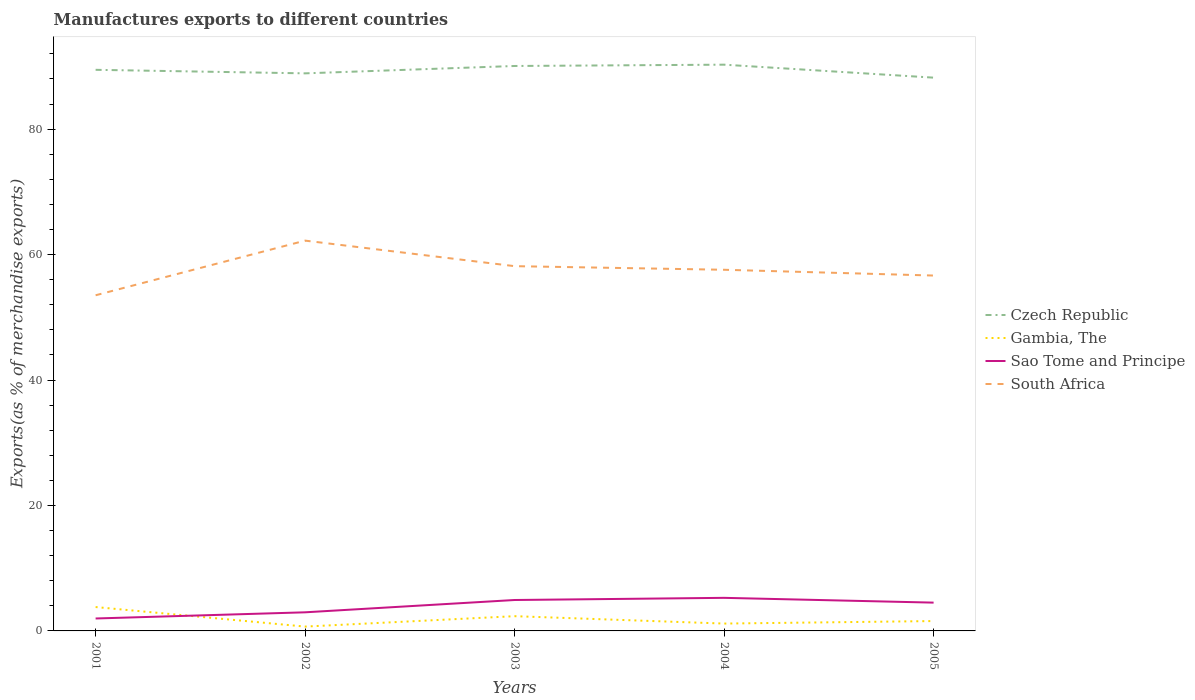Does the line corresponding to Gambia, The intersect with the line corresponding to Sao Tome and Principe?
Your answer should be compact. Yes. Is the number of lines equal to the number of legend labels?
Your answer should be compact. Yes. Across all years, what is the maximum percentage of exports to different countries in Sao Tome and Principe?
Give a very brief answer. 1.98. What is the total percentage of exports to different countries in Czech Republic in the graph?
Make the answer very short. 0.68. What is the difference between the highest and the second highest percentage of exports to different countries in South Africa?
Provide a succinct answer. 8.71. How many lines are there?
Provide a short and direct response. 4. How many years are there in the graph?
Your answer should be compact. 5. Are the values on the major ticks of Y-axis written in scientific E-notation?
Give a very brief answer. No. Does the graph contain grids?
Offer a very short reply. No. Where does the legend appear in the graph?
Your answer should be compact. Center right. How many legend labels are there?
Provide a succinct answer. 4. How are the legend labels stacked?
Make the answer very short. Vertical. What is the title of the graph?
Ensure brevity in your answer.  Manufactures exports to different countries. What is the label or title of the Y-axis?
Your answer should be very brief. Exports(as % of merchandise exports). What is the Exports(as % of merchandise exports) of Czech Republic in 2001?
Your response must be concise. 89.45. What is the Exports(as % of merchandise exports) of Gambia, The in 2001?
Provide a short and direct response. 3.81. What is the Exports(as % of merchandise exports) of Sao Tome and Principe in 2001?
Offer a very short reply. 1.98. What is the Exports(as % of merchandise exports) in South Africa in 2001?
Give a very brief answer. 53.51. What is the Exports(as % of merchandise exports) in Czech Republic in 2002?
Provide a short and direct response. 88.89. What is the Exports(as % of merchandise exports) in Gambia, The in 2002?
Ensure brevity in your answer.  0.69. What is the Exports(as % of merchandise exports) of Sao Tome and Principe in 2002?
Your answer should be very brief. 2.97. What is the Exports(as % of merchandise exports) in South Africa in 2002?
Offer a terse response. 62.22. What is the Exports(as % of merchandise exports) in Czech Republic in 2003?
Offer a very short reply. 90.07. What is the Exports(as % of merchandise exports) of Gambia, The in 2003?
Provide a succinct answer. 2.35. What is the Exports(as % of merchandise exports) of Sao Tome and Principe in 2003?
Offer a very short reply. 4.93. What is the Exports(as % of merchandise exports) in South Africa in 2003?
Offer a very short reply. 58.15. What is the Exports(as % of merchandise exports) in Czech Republic in 2004?
Keep it short and to the point. 90.27. What is the Exports(as % of merchandise exports) of Gambia, The in 2004?
Your response must be concise. 1.17. What is the Exports(as % of merchandise exports) of Sao Tome and Principe in 2004?
Make the answer very short. 5.27. What is the Exports(as % of merchandise exports) of South Africa in 2004?
Give a very brief answer. 57.58. What is the Exports(as % of merchandise exports) of Czech Republic in 2005?
Offer a very short reply. 88.21. What is the Exports(as % of merchandise exports) in Gambia, The in 2005?
Offer a terse response. 1.57. What is the Exports(as % of merchandise exports) of Sao Tome and Principe in 2005?
Your answer should be compact. 4.51. What is the Exports(as % of merchandise exports) of South Africa in 2005?
Make the answer very short. 56.66. Across all years, what is the maximum Exports(as % of merchandise exports) of Czech Republic?
Keep it short and to the point. 90.27. Across all years, what is the maximum Exports(as % of merchandise exports) in Gambia, The?
Your answer should be compact. 3.81. Across all years, what is the maximum Exports(as % of merchandise exports) of Sao Tome and Principe?
Provide a short and direct response. 5.27. Across all years, what is the maximum Exports(as % of merchandise exports) in South Africa?
Make the answer very short. 62.22. Across all years, what is the minimum Exports(as % of merchandise exports) in Czech Republic?
Offer a terse response. 88.21. Across all years, what is the minimum Exports(as % of merchandise exports) of Gambia, The?
Provide a short and direct response. 0.69. Across all years, what is the minimum Exports(as % of merchandise exports) in Sao Tome and Principe?
Ensure brevity in your answer.  1.98. Across all years, what is the minimum Exports(as % of merchandise exports) in South Africa?
Ensure brevity in your answer.  53.51. What is the total Exports(as % of merchandise exports) of Czech Republic in the graph?
Your answer should be very brief. 446.89. What is the total Exports(as % of merchandise exports) of Gambia, The in the graph?
Your answer should be very brief. 9.59. What is the total Exports(as % of merchandise exports) in Sao Tome and Principe in the graph?
Make the answer very short. 19.66. What is the total Exports(as % of merchandise exports) in South Africa in the graph?
Your answer should be very brief. 288.12. What is the difference between the Exports(as % of merchandise exports) of Czech Republic in 2001 and that in 2002?
Provide a short and direct response. 0.56. What is the difference between the Exports(as % of merchandise exports) of Gambia, The in 2001 and that in 2002?
Keep it short and to the point. 3.12. What is the difference between the Exports(as % of merchandise exports) of Sao Tome and Principe in 2001 and that in 2002?
Make the answer very short. -0.98. What is the difference between the Exports(as % of merchandise exports) of South Africa in 2001 and that in 2002?
Ensure brevity in your answer.  -8.71. What is the difference between the Exports(as % of merchandise exports) of Czech Republic in 2001 and that in 2003?
Your answer should be very brief. -0.61. What is the difference between the Exports(as % of merchandise exports) in Gambia, The in 2001 and that in 2003?
Keep it short and to the point. 1.46. What is the difference between the Exports(as % of merchandise exports) of Sao Tome and Principe in 2001 and that in 2003?
Your answer should be compact. -2.95. What is the difference between the Exports(as % of merchandise exports) of South Africa in 2001 and that in 2003?
Offer a terse response. -4.64. What is the difference between the Exports(as % of merchandise exports) of Czech Republic in 2001 and that in 2004?
Make the answer very short. -0.82. What is the difference between the Exports(as % of merchandise exports) in Gambia, The in 2001 and that in 2004?
Ensure brevity in your answer.  2.63. What is the difference between the Exports(as % of merchandise exports) in Sao Tome and Principe in 2001 and that in 2004?
Give a very brief answer. -3.29. What is the difference between the Exports(as % of merchandise exports) of South Africa in 2001 and that in 2004?
Your answer should be compact. -4.06. What is the difference between the Exports(as % of merchandise exports) of Czech Republic in 2001 and that in 2005?
Provide a succinct answer. 1.25. What is the difference between the Exports(as % of merchandise exports) of Gambia, The in 2001 and that in 2005?
Give a very brief answer. 2.23. What is the difference between the Exports(as % of merchandise exports) in Sao Tome and Principe in 2001 and that in 2005?
Your response must be concise. -2.53. What is the difference between the Exports(as % of merchandise exports) in South Africa in 2001 and that in 2005?
Your answer should be compact. -3.14. What is the difference between the Exports(as % of merchandise exports) in Czech Republic in 2002 and that in 2003?
Your answer should be very brief. -1.17. What is the difference between the Exports(as % of merchandise exports) in Gambia, The in 2002 and that in 2003?
Your answer should be very brief. -1.66. What is the difference between the Exports(as % of merchandise exports) of Sao Tome and Principe in 2002 and that in 2003?
Give a very brief answer. -1.96. What is the difference between the Exports(as % of merchandise exports) of South Africa in 2002 and that in 2003?
Ensure brevity in your answer.  4.07. What is the difference between the Exports(as % of merchandise exports) of Czech Republic in 2002 and that in 2004?
Ensure brevity in your answer.  -1.38. What is the difference between the Exports(as % of merchandise exports) of Gambia, The in 2002 and that in 2004?
Keep it short and to the point. -0.48. What is the difference between the Exports(as % of merchandise exports) of Sao Tome and Principe in 2002 and that in 2004?
Ensure brevity in your answer.  -2.31. What is the difference between the Exports(as % of merchandise exports) in South Africa in 2002 and that in 2004?
Your response must be concise. 4.65. What is the difference between the Exports(as % of merchandise exports) of Czech Republic in 2002 and that in 2005?
Your answer should be very brief. 0.68. What is the difference between the Exports(as % of merchandise exports) in Gambia, The in 2002 and that in 2005?
Offer a very short reply. -0.88. What is the difference between the Exports(as % of merchandise exports) of Sao Tome and Principe in 2002 and that in 2005?
Your answer should be very brief. -1.54. What is the difference between the Exports(as % of merchandise exports) in South Africa in 2002 and that in 2005?
Give a very brief answer. 5.57. What is the difference between the Exports(as % of merchandise exports) of Czech Republic in 2003 and that in 2004?
Your answer should be compact. -0.21. What is the difference between the Exports(as % of merchandise exports) of Gambia, The in 2003 and that in 2004?
Offer a terse response. 1.18. What is the difference between the Exports(as % of merchandise exports) of Sao Tome and Principe in 2003 and that in 2004?
Make the answer very short. -0.34. What is the difference between the Exports(as % of merchandise exports) of South Africa in 2003 and that in 2004?
Ensure brevity in your answer.  0.58. What is the difference between the Exports(as % of merchandise exports) of Czech Republic in 2003 and that in 2005?
Make the answer very short. 1.86. What is the difference between the Exports(as % of merchandise exports) of Gambia, The in 2003 and that in 2005?
Offer a terse response. 0.78. What is the difference between the Exports(as % of merchandise exports) in Sao Tome and Principe in 2003 and that in 2005?
Offer a very short reply. 0.42. What is the difference between the Exports(as % of merchandise exports) of South Africa in 2003 and that in 2005?
Offer a very short reply. 1.5. What is the difference between the Exports(as % of merchandise exports) in Czech Republic in 2004 and that in 2005?
Your answer should be compact. 2.07. What is the difference between the Exports(as % of merchandise exports) of Gambia, The in 2004 and that in 2005?
Keep it short and to the point. -0.4. What is the difference between the Exports(as % of merchandise exports) in Sao Tome and Principe in 2004 and that in 2005?
Your answer should be very brief. 0.76. What is the difference between the Exports(as % of merchandise exports) in South Africa in 2004 and that in 2005?
Offer a very short reply. 0.92. What is the difference between the Exports(as % of merchandise exports) of Czech Republic in 2001 and the Exports(as % of merchandise exports) of Gambia, The in 2002?
Make the answer very short. 88.76. What is the difference between the Exports(as % of merchandise exports) in Czech Republic in 2001 and the Exports(as % of merchandise exports) in Sao Tome and Principe in 2002?
Provide a succinct answer. 86.49. What is the difference between the Exports(as % of merchandise exports) of Czech Republic in 2001 and the Exports(as % of merchandise exports) of South Africa in 2002?
Offer a terse response. 27.23. What is the difference between the Exports(as % of merchandise exports) in Gambia, The in 2001 and the Exports(as % of merchandise exports) in Sao Tome and Principe in 2002?
Make the answer very short. 0.84. What is the difference between the Exports(as % of merchandise exports) of Gambia, The in 2001 and the Exports(as % of merchandise exports) of South Africa in 2002?
Offer a very short reply. -58.42. What is the difference between the Exports(as % of merchandise exports) in Sao Tome and Principe in 2001 and the Exports(as % of merchandise exports) in South Africa in 2002?
Your response must be concise. -60.24. What is the difference between the Exports(as % of merchandise exports) of Czech Republic in 2001 and the Exports(as % of merchandise exports) of Gambia, The in 2003?
Ensure brevity in your answer.  87.1. What is the difference between the Exports(as % of merchandise exports) in Czech Republic in 2001 and the Exports(as % of merchandise exports) in Sao Tome and Principe in 2003?
Your answer should be very brief. 84.52. What is the difference between the Exports(as % of merchandise exports) in Czech Republic in 2001 and the Exports(as % of merchandise exports) in South Africa in 2003?
Your answer should be compact. 31.3. What is the difference between the Exports(as % of merchandise exports) of Gambia, The in 2001 and the Exports(as % of merchandise exports) of Sao Tome and Principe in 2003?
Your response must be concise. -1.12. What is the difference between the Exports(as % of merchandise exports) in Gambia, The in 2001 and the Exports(as % of merchandise exports) in South Africa in 2003?
Give a very brief answer. -54.35. What is the difference between the Exports(as % of merchandise exports) in Sao Tome and Principe in 2001 and the Exports(as % of merchandise exports) in South Africa in 2003?
Ensure brevity in your answer.  -56.17. What is the difference between the Exports(as % of merchandise exports) of Czech Republic in 2001 and the Exports(as % of merchandise exports) of Gambia, The in 2004?
Offer a terse response. 88.28. What is the difference between the Exports(as % of merchandise exports) of Czech Republic in 2001 and the Exports(as % of merchandise exports) of Sao Tome and Principe in 2004?
Give a very brief answer. 84.18. What is the difference between the Exports(as % of merchandise exports) in Czech Republic in 2001 and the Exports(as % of merchandise exports) in South Africa in 2004?
Your answer should be very brief. 31.88. What is the difference between the Exports(as % of merchandise exports) in Gambia, The in 2001 and the Exports(as % of merchandise exports) in Sao Tome and Principe in 2004?
Make the answer very short. -1.47. What is the difference between the Exports(as % of merchandise exports) in Gambia, The in 2001 and the Exports(as % of merchandise exports) in South Africa in 2004?
Offer a very short reply. -53.77. What is the difference between the Exports(as % of merchandise exports) of Sao Tome and Principe in 2001 and the Exports(as % of merchandise exports) of South Africa in 2004?
Your answer should be compact. -55.59. What is the difference between the Exports(as % of merchandise exports) of Czech Republic in 2001 and the Exports(as % of merchandise exports) of Gambia, The in 2005?
Your answer should be very brief. 87.88. What is the difference between the Exports(as % of merchandise exports) of Czech Republic in 2001 and the Exports(as % of merchandise exports) of Sao Tome and Principe in 2005?
Your answer should be compact. 84.94. What is the difference between the Exports(as % of merchandise exports) in Czech Republic in 2001 and the Exports(as % of merchandise exports) in South Africa in 2005?
Offer a very short reply. 32.8. What is the difference between the Exports(as % of merchandise exports) of Gambia, The in 2001 and the Exports(as % of merchandise exports) of Sao Tome and Principe in 2005?
Offer a terse response. -0.7. What is the difference between the Exports(as % of merchandise exports) of Gambia, The in 2001 and the Exports(as % of merchandise exports) of South Africa in 2005?
Offer a terse response. -52.85. What is the difference between the Exports(as % of merchandise exports) in Sao Tome and Principe in 2001 and the Exports(as % of merchandise exports) in South Africa in 2005?
Provide a short and direct response. -54.67. What is the difference between the Exports(as % of merchandise exports) of Czech Republic in 2002 and the Exports(as % of merchandise exports) of Gambia, The in 2003?
Provide a short and direct response. 86.54. What is the difference between the Exports(as % of merchandise exports) in Czech Republic in 2002 and the Exports(as % of merchandise exports) in Sao Tome and Principe in 2003?
Your response must be concise. 83.96. What is the difference between the Exports(as % of merchandise exports) of Czech Republic in 2002 and the Exports(as % of merchandise exports) of South Africa in 2003?
Keep it short and to the point. 30.74. What is the difference between the Exports(as % of merchandise exports) in Gambia, The in 2002 and the Exports(as % of merchandise exports) in Sao Tome and Principe in 2003?
Your response must be concise. -4.24. What is the difference between the Exports(as % of merchandise exports) in Gambia, The in 2002 and the Exports(as % of merchandise exports) in South Africa in 2003?
Give a very brief answer. -57.46. What is the difference between the Exports(as % of merchandise exports) of Sao Tome and Principe in 2002 and the Exports(as % of merchandise exports) of South Africa in 2003?
Make the answer very short. -55.19. What is the difference between the Exports(as % of merchandise exports) of Czech Republic in 2002 and the Exports(as % of merchandise exports) of Gambia, The in 2004?
Your answer should be compact. 87.72. What is the difference between the Exports(as % of merchandise exports) of Czech Republic in 2002 and the Exports(as % of merchandise exports) of Sao Tome and Principe in 2004?
Your response must be concise. 83.62. What is the difference between the Exports(as % of merchandise exports) of Czech Republic in 2002 and the Exports(as % of merchandise exports) of South Africa in 2004?
Offer a very short reply. 31.31. What is the difference between the Exports(as % of merchandise exports) of Gambia, The in 2002 and the Exports(as % of merchandise exports) of Sao Tome and Principe in 2004?
Make the answer very short. -4.58. What is the difference between the Exports(as % of merchandise exports) in Gambia, The in 2002 and the Exports(as % of merchandise exports) in South Africa in 2004?
Offer a terse response. -56.89. What is the difference between the Exports(as % of merchandise exports) in Sao Tome and Principe in 2002 and the Exports(as % of merchandise exports) in South Africa in 2004?
Give a very brief answer. -54.61. What is the difference between the Exports(as % of merchandise exports) of Czech Republic in 2002 and the Exports(as % of merchandise exports) of Gambia, The in 2005?
Give a very brief answer. 87.32. What is the difference between the Exports(as % of merchandise exports) in Czech Republic in 2002 and the Exports(as % of merchandise exports) in Sao Tome and Principe in 2005?
Keep it short and to the point. 84.38. What is the difference between the Exports(as % of merchandise exports) of Czech Republic in 2002 and the Exports(as % of merchandise exports) of South Africa in 2005?
Offer a terse response. 32.24. What is the difference between the Exports(as % of merchandise exports) of Gambia, The in 2002 and the Exports(as % of merchandise exports) of Sao Tome and Principe in 2005?
Offer a very short reply. -3.82. What is the difference between the Exports(as % of merchandise exports) of Gambia, The in 2002 and the Exports(as % of merchandise exports) of South Africa in 2005?
Give a very brief answer. -55.96. What is the difference between the Exports(as % of merchandise exports) in Sao Tome and Principe in 2002 and the Exports(as % of merchandise exports) in South Africa in 2005?
Your response must be concise. -53.69. What is the difference between the Exports(as % of merchandise exports) in Czech Republic in 2003 and the Exports(as % of merchandise exports) in Gambia, The in 2004?
Give a very brief answer. 88.89. What is the difference between the Exports(as % of merchandise exports) of Czech Republic in 2003 and the Exports(as % of merchandise exports) of Sao Tome and Principe in 2004?
Offer a terse response. 84.79. What is the difference between the Exports(as % of merchandise exports) of Czech Republic in 2003 and the Exports(as % of merchandise exports) of South Africa in 2004?
Ensure brevity in your answer.  32.49. What is the difference between the Exports(as % of merchandise exports) in Gambia, The in 2003 and the Exports(as % of merchandise exports) in Sao Tome and Principe in 2004?
Give a very brief answer. -2.92. What is the difference between the Exports(as % of merchandise exports) of Gambia, The in 2003 and the Exports(as % of merchandise exports) of South Africa in 2004?
Provide a succinct answer. -55.23. What is the difference between the Exports(as % of merchandise exports) in Sao Tome and Principe in 2003 and the Exports(as % of merchandise exports) in South Africa in 2004?
Your response must be concise. -52.65. What is the difference between the Exports(as % of merchandise exports) of Czech Republic in 2003 and the Exports(as % of merchandise exports) of Gambia, The in 2005?
Provide a short and direct response. 88.49. What is the difference between the Exports(as % of merchandise exports) in Czech Republic in 2003 and the Exports(as % of merchandise exports) in Sao Tome and Principe in 2005?
Give a very brief answer. 85.55. What is the difference between the Exports(as % of merchandise exports) of Czech Republic in 2003 and the Exports(as % of merchandise exports) of South Africa in 2005?
Keep it short and to the point. 33.41. What is the difference between the Exports(as % of merchandise exports) in Gambia, The in 2003 and the Exports(as % of merchandise exports) in Sao Tome and Principe in 2005?
Offer a very short reply. -2.16. What is the difference between the Exports(as % of merchandise exports) of Gambia, The in 2003 and the Exports(as % of merchandise exports) of South Africa in 2005?
Provide a short and direct response. -54.31. What is the difference between the Exports(as % of merchandise exports) of Sao Tome and Principe in 2003 and the Exports(as % of merchandise exports) of South Africa in 2005?
Give a very brief answer. -51.73. What is the difference between the Exports(as % of merchandise exports) in Czech Republic in 2004 and the Exports(as % of merchandise exports) in Gambia, The in 2005?
Ensure brevity in your answer.  88.7. What is the difference between the Exports(as % of merchandise exports) in Czech Republic in 2004 and the Exports(as % of merchandise exports) in Sao Tome and Principe in 2005?
Provide a succinct answer. 85.76. What is the difference between the Exports(as % of merchandise exports) in Czech Republic in 2004 and the Exports(as % of merchandise exports) in South Africa in 2005?
Offer a terse response. 33.62. What is the difference between the Exports(as % of merchandise exports) of Gambia, The in 2004 and the Exports(as % of merchandise exports) of Sao Tome and Principe in 2005?
Your answer should be very brief. -3.34. What is the difference between the Exports(as % of merchandise exports) of Gambia, The in 2004 and the Exports(as % of merchandise exports) of South Africa in 2005?
Your response must be concise. -55.48. What is the difference between the Exports(as % of merchandise exports) in Sao Tome and Principe in 2004 and the Exports(as % of merchandise exports) in South Africa in 2005?
Give a very brief answer. -51.38. What is the average Exports(as % of merchandise exports) in Czech Republic per year?
Provide a succinct answer. 89.38. What is the average Exports(as % of merchandise exports) in Gambia, The per year?
Your answer should be very brief. 1.92. What is the average Exports(as % of merchandise exports) in Sao Tome and Principe per year?
Offer a terse response. 3.93. What is the average Exports(as % of merchandise exports) in South Africa per year?
Give a very brief answer. 57.62. In the year 2001, what is the difference between the Exports(as % of merchandise exports) in Czech Republic and Exports(as % of merchandise exports) in Gambia, The?
Offer a terse response. 85.65. In the year 2001, what is the difference between the Exports(as % of merchandise exports) of Czech Republic and Exports(as % of merchandise exports) of Sao Tome and Principe?
Offer a terse response. 87.47. In the year 2001, what is the difference between the Exports(as % of merchandise exports) in Czech Republic and Exports(as % of merchandise exports) in South Africa?
Provide a succinct answer. 35.94. In the year 2001, what is the difference between the Exports(as % of merchandise exports) in Gambia, The and Exports(as % of merchandise exports) in Sao Tome and Principe?
Your response must be concise. 1.82. In the year 2001, what is the difference between the Exports(as % of merchandise exports) in Gambia, The and Exports(as % of merchandise exports) in South Africa?
Make the answer very short. -49.71. In the year 2001, what is the difference between the Exports(as % of merchandise exports) of Sao Tome and Principe and Exports(as % of merchandise exports) of South Africa?
Make the answer very short. -51.53. In the year 2002, what is the difference between the Exports(as % of merchandise exports) in Czech Republic and Exports(as % of merchandise exports) in Gambia, The?
Offer a very short reply. 88.2. In the year 2002, what is the difference between the Exports(as % of merchandise exports) of Czech Republic and Exports(as % of merchandise exports) of Sao Tome and Principe?
Give a very brief answer. 85.92. In the year 2002, what is the difference between the Exports(as % of merchandise exports) of Czech Republic and Exports(as % of merchandise exports) of South Africa?
Your response must be concise. 26.67. In the year 2002, what is the difference between the Exports(as % of merchandise exports) in Gambia, The and Exports(as % of merchandise exports) in Sao Tome and Principe?
Give a very brief answer. -2.28. In the year 2002, what is the difference between the Exports(as % of merchandise exports) in Gambia, The and Exports(as % of merchandise exports) in South Africa?
Provide a short and direct response. -61.53. In the year 2002, what is the difference between the Exports(as % of merchandise exports) of Sao Tome and Principe and Exports(as % of merchandise exports) of South Africa?
Ensure brevity in your answer.  -59.26. In the year 2003, what is the difference between the Exports(as % of merchandise exports) in Czech Republic and Exports(as % of merchandise exports) in Gambia, The?
Make the answer very short. 87.72. In the year 2003, what is the difference between the Exports(as % of merchandise exports) of Czech Republic and Exports(as % of merchandise exports) of Sao Tome and Principe?
Provide a short and direct response. 85.14. In the year 2003, what is the difference between the Exports(as % of merchandise exports) of Czech Republic and Exports(as % of merchandise exports) of South Africa?
Keep it short and to the point. 31.91. In the year 2003, what is the difference between the Exports(as % of merchandise exports) in Gambia, The and Exports(as % of merchandise exports) in Sao Tome and Principe?
Your response must be concise. -2.58. In the year 2003, what is the difference between the Exports(as % of merchandise exports) of Gambia, The and Exports(as % of merchandise exports) of South Africa?
Keep it short and to the point. -55.8. In the year 2003, what is the difference between the Exports(as % of merchandise exports) in Sao Tome and Principe and Exports(as % of merchandise exports) in South Africa?
Make the answer very short. -53.22. In the year 2004, what is the difference between the Exports(as % of merchandise exports) in Czech Republic and Exports(as % of merchandise exports) in Gambia, The?
Your answer should be compact. 89.1. In the year 2004, what is the difference between the Exports(as % of merchandise exports) in Czech Republic and Exports(as % of merchandise exports) in Sao Tome and Principe?
Keep it short and to the point. 85. In the year 2004, what is the difference between the Exports(as % of merchandise exports) in Czech Republic and Exports(as % of merchandise exports) in South Africa?
Make the answer very short. 32.7. In the year 2004, what is the difference between the Exports(as % of merchandise exports) of Gambia, The and Exports(as % of merchandise exports) of Sao Tome and Principe?
Give a very brief answer. -4.1. In the year 2004, what is the difference between the Exports(as % of merchandise exports) of Gambia, The and Exports(as % of merchandise exports) of South Africa?
Your response must be concise. -56.4. In the year 2004, what is the difference between the Exports(as % of merchandise exports) in Sao Tome and Principe and Exports(as % of merchandise exports) in South Africa?
Your answer should be very brief. -52.3. In the year 2005, what is the difference between the Exports(as % of merchandise exports) in Czech Republic and Exports(as % of merchandise exports) in Gambia, The?
Give a very brief answer. 86.63. In the year 2005, what is the difference between the Exports(as % of merchandise exports) of Czech Republic and Exports(as % of merchandise exports) of Sao Tome and Principe?
Your answer should be very brief. 83.69. In the year 2005, what is the difference between the Exports(as % of merchandise exports) in Czech Republic and Exports(as % of merchandise exports) in South Africa?
Make the answer very short. 31.55. In the year 2005, what is the difference between the Exports(as % of merchandise exports) of Gambia, The and Exports(as % of merchandise exports) of Sao Tome and Principe?
Make the answer very short. -2.94. In the year 2005, what is the difference between the Exports(as % of merchandise exports) of Gambia, The and Exports(as % of merchandise exports) of South Africa?
Offer a terse response. -55.08. In the year 2005, what is the difference between the Exports(as % of merchandise exports) of Sao Tome and Principe and Exports(as % of merchandise exports) of South Africa?
Offer a terse response. -52.14. What is the ratio of the Exports(as % of merchandise exports) in Gambia, The in 2001 to that in 2002?
Ensure brevity in your answer.  5.51. What is the ratio of the Exports(as % of merchandise exports) in Sao Tome and Principe in 2001 to that in 2002?
Your response must be concise. 0.67. What is the ratio of the Exports(as % of merchandise exports) in South Africa in 2001 to that in 2002?
Your answer should be compact. 0.86. What is the ratio of the Exports(as % of merchandise exports) of Gambia, The in 2001 to that in 2003?
Offer a very short reply. 1.62. What is the ratio of the Exports(as % of merchandise exports) in Sao Tome and Principe in 2001 to that in 2003?
Offer a very short reply. 0.4. What is the ratio of the Exports(as % of merchandise exports) of South Africa in 2001 to that in 2003?
Provide a succinct answer. 0.92. What is the ratio of the Exports(as % of merchandise exports) in Czech Republic in 2001 to that in 2004?
Keep it short and to the point. 0.99. What is the ratio of the Exports(as % of merchandise exports) of Gambia, The in 2001 to that in 2004?
Give a very brief answer. 3.25. What is the ratio of the Exports(as % of merchandise exports) of Sao Tome and Principe in 2001 to that in 2004?
Provide a succinct answer. 0.38. What is the ratio of the Exports(as % of merchandise exports) in South Africa in 2001 to that in 2004?
Keep it short and to the point. 0.93. What is the ratio of the Exports(as % of merchandise exports) of Czech Republic in 2001 to that in 2005?
Your response must be concise. 1.01. What is the ratio of the Exports(as % of merchandise exports) of Gambia, The in 2001 to that in 2005?
Offer a very short reply. 2.42. What is the ratio of the Exports(as % of merchandise exports) of Sao Tome and Principe in 2001 to that in 2005?
Provide a succinct answer. 0.44. What is the ratio of the Exports(as % of merchandise exports) in South Africa in 2001 to that in 2005?
Ensure brevity in your answer.  0.94. What is the ratio of the Exports(as % of merchandise exports) in Gambia, The in 2002 to that in 2003?
Ensure brevity in your answer.  0.29. What is the ratio of the Exports(as % of merchandise exports) in Sao Tome and Principe in 2002 to that in 2003?
Provide a short and direct response. 0.6. What is the ratio of the Exports(as % of merchandise exports) of South Africa in 2002 to that in 2003?
Your answer should be compact. 1.07. What is the ratio of the Exports(as % of merchandise exports) of Czech Republic in 2002 to that in 2004?
Your answer should be compact. 0.98. What is the ratio of the Exports(as % of merchandise exports) of Gambia, The in 2002 to that in 2004?
Offer a very short reply. 0.59. What is the ratio of the Exports(as % of merchandise exports) of Sao Tome and Principe in 2002 to that in 2004?
Provide a short and direct response. 0.56. What is the ratio of the Exports(as % of merchandise exports) of South Africa in 2002 to that in 2004?
Your answer should be very brief. 1.08. What is the ratio of the Exports(as % of merchandise exports) of Gambia, The in 2002 to that in 2005?
Offer a terse response. 0.44. What is the ratio of the Exports(as % of merchandise exports) in Sao Tome and Principe in 2002 to that in 2005?
Make the answer very short. 0.66. What is the ratio of the Exports(as % of merchandise exports) of South Africa in 2002 to that in 2005?
Provide a succinct answer. 1.1. What is the ratio of the Exports(as % of merchandise exports) of Gambia, The in 2003 to that in 2004?
Your answer should be very brief. 2. What is the ratio of the Exports(as % of merchandise exports) in Sao Tome and Principe in 2003 to that in 2004?
Give a very brief answer. 0.94. What is the ratio of the Exports(as % of merchandise exports) in South Africa in 2003 to that in 2004?
Give a very brief answer. 1.01. What is the ratio of the Exports(as % of merchandise exports) in Czech Republic in 2003 to that in 2005?
Provide a short and direct response. 1.02. What is the ratio of the Exports(as % of merchandise exports) of Gambia, The in 2003 to that in 2005?
Provide a short and direct response. 1.49. What is the ratio of the Exports(as % of merchandise exports) of Sao Tome and Principe in 2003 to that in 2005?
Ensure brevity in your answer.  1.09. What is the ratio of the Exports(as % of merchandise exports) in South Africa in 2003 to that in 2005?
Offer a terse response. 1.03. What is the ratio of the Exports(as % of merchandise exports) in Czech Republic in 2004 to that in 2005?
Keep it short and to the point. 1.02. What is the ratio of the Exports(as % of merchandise exports) of Gambia, The in 2004 to that in 2005?
Ensure brevity in your answer.  0.75. What is the ratio of the Exports(as % of merchandise exports) in Sao Tome and Principe in 2004 to that in 2005?
Offer a very short reply. 1.17. What is the ratio of the Exports(as % of merchandise exports) of South Africa in 2004 to that in 2005?
Keep it short and to the point. 1.02. What is the difference between the highest and the second highest Exports(as % of merchandise exports) in Czech Republic?
Give a very brief answer. 0.21. What is the difference between the highest and the second highest Exports(as % of merchandise exports) of Gambia, The?
Give a very brief answer. 1.46. What is the difference between the highest and the second highest Exports(as % of merchandise exports) of Sao Tome and Principe?
Your response must be concise. 0.34. What is the difference between the highest and the second highest Exports(as % of merchandise exports) in South Africa?
Offer a very short reply. 4.07. What is the difference between the highest and the lowest Exports(as % of merchandise exports) in Czech Republic?
Your answer should be very brief. 2.07. What is the difference between the highest and the lowest Exports(as % of merchandise exports) of Gambia, The?
Offer a terse response. 3.12. What is the difference between the highest and the lowest Exports(as % of merchandise exports) in Sao Tome and Principe?
Provide a succinct answer. 3.29. What is the difference between the highest and the lowest Exports(as % of merchandise exports) of South Africa?
Provide a succinct answer. 8.71. 